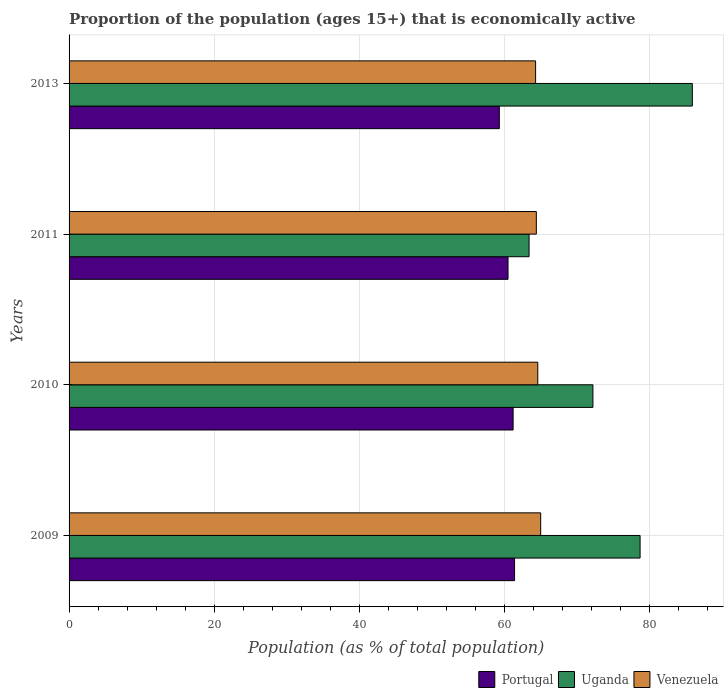How many groups of bars are there?
Provide a succinct answer. 4. Are the number of bars per tick equal to the number of legend labels?
Offer a very short reply. Yes. Are the number of bars on each tick of the Y-axis equal?
Provide a succinct answer. Yes. How many bars are there on the 3rd tick from the top?
Keep it short and to the point. 3. What is the proportion of the population that is economically active in Venezuela in 2010?
Offer a very short reply. 64.6. Across all years, what is the maximum proportion of the population that is economically active in Venezuela?
Keep it short and to the point. 65. Across all years, what is the minimum proportion of the population that is economically active in Venezuela?
Give a very brief answer. 64.3. In which year was the proportion of the population that is economically active in Venezuela minimum?
Give a very brief answer. 2013. What is the total proportion of the population that is economically active in Venezuela in the graph?
Provide a succinct answer. 258.3. What is the difference between the proportion of the population that is economically active in Venezuela in 2009 and that in 2010?
Keep it short and to the point. 0.4. What is the difference between the proportion of the population that is economically active in Portugal in 2009 and the proportion of the population that is economically active in Venezuela in 2011?
Provide a short and direct response. -3. What is the average proportion of the population that is economically active in Uganda per year?
Your answer should be very brief. 75.05. In the year 2011, what is the difference between the proportion of the population that is economically active in Venezuela and proportion of the population that is economically active in Portugal?
Keep it short and to the point. 3.9. In how many years, is the proportion of the population that is economically active in Venezuela greater than 20 %?
Your answer should be very brief. 4. What is the ratio of the proportion of the population that is economically active in Uganda in 2010 to that in 2011?
Offer a very short reply. 1.14. Is the proportion of the population that is economically active in Uganda in 2009 less than that in 2013?
Your answer should be very brief. Yes. What is the difference between the highest and the second highest proportion of the population that is economically active in Venezuela?
Your response must be concise. 0.4. What is the difference between the highest and the lowest proportion of the population that is economically active in Uganda?
Make the answer very short. 22.5. What does the 2nd bar from the top in 2010 represents?
Make the answer very short. Uganda. What does the 2nd bar from the bottom in 2009 represents?
Give a very brief answer. Uganda. Is it the case that in every year, the sum of the proportion of the population that is economically active in Venezuela and proportion of the population that is economically active in Uganda is greater than the proportion of the population that is economically active in Portugal?
Provide a short and direct response. Yes. Does the graph contain any zero values?
Offer a very short reply. No. How are the legend labels stacked?
Ensure brevity in your answer.  Horizontal. What is the title of the graph?
Provide a short and direct response. Proportion of the population (ages 15+) that is economically active. What is the label or title of the X-axis?
Provide a succinct answer. Population (as % of total population). What is the Population (as % of total population) of Portugal in 2009?
Keep it short and to the point. 61.4. What is the Population (as % of total population) of Uganda in 2009?
Your answer should be very brief. 78.7. What is the Population (as % of total population) in Venezuela in 2009?
Offer a terse response. 65. What is the Population (as % of total population) of Portugal in 2010?
Provide a short and direct response. 61.2. What is the Population (as % of total population) of Uganda in 2010?
Your response must be concise. 72.2. What is the Population (as % of total population) of Venezuela in 2010?
Your answer should be compact. 64.6. What is the Population (as % of total population) of Portugal in 2011?
Provide a succinct answer. 60.5. What is the Population (as % of total population) of Uganda in 2011?
Provide a succinct answer. 63.4. What is the Population (as % of total population) of Venezuela in 2011?
Provide a short and direct response. 64.4. What is the Population (as % of total population) in Portugal in 2013?
Provide a short and direct response. 59.3. What is the Population (as % of total population) in Uganda in 2013?
Offer a very short reply. 85.9. What is the Population (as % of total population) of Venezuela in 2013?
Make the answer very short. 64.3. Across all years, what is the maximum Population (as % of total population) in Portugal?
Offer a very short reply. 61.4. Across all years, what is the maximum Population (as % of total population) in Uganda?
Your answer should be very brief. 85.9. Across all years, what is the maximum Population (as % of total population) in Venezuela?
Your answer should be very brief. 65. Across all years, what is the minimum Population (as % of total population) of Portugal?
Offer a terse response. 59.3. Across all years, what is the minimum Population (as % of total population) of Uganda?
Provide a short and direct response. 63.4. Across all years, what is the minimum Population (as % of total population) of Venezuela?
Make the answer very short. 64.3. What is the total Population (as % of total population) in Portugal in the graph?
Keep it short and to the point. 242.4. What is the total Population (as % of total population) of Uganda in the graph?
Keep it short and to the point. 300.2. What is the total Population (as % of total population) in Venezuela in the graph?
Ensure brevity in your answer.  258.3. What is the difference between the Population (as % of total population) of Portugal in 2009 and that in 2010?
Your answer should be compact. 0.2. What is the difference between the Population (as % of total population) of Uganda in 2009 and that in 2010?
Provide a short and direct response. 6.5. What is the difference between the Population (as % of total population) of Uganda in 2009 and that in 2011?
Ensure brevity in your answer.  15.3. What is the difference between the Population (as % of total population) of Portugal in 2009 and that in 2013?
Ensure brevity in your answer.  2.1. What is the difference between the Population (as % of total population) in Uganda in 2009 and that in 2013?
Ensure brevity in your answer.  -7.2. What is the difference between the Population (as % of total population) of Venezuela in 2009 and that in 2013?
Provide a short and direct response. 0.7. What is the difference between the Population (as % of total population) in Uganda in 2010 and that in 2011?
Keep it short and to the point. 8.8. What is the difference between the Population (as % of total population) of Uganda in 2010 and that in 2013?
Offer a very short reply. -13.7. What is the difference between the Population (as % of total population) in Venezuela in 2010 and that in 2013?
Offer a very short reply. 0.3. What is the difference between the Population (as % of total population) in Portugal in 2011 and that in 2013?
Provide a short and direct response. 1.2. What is the difference between the Population (as % of total population) in Uganda in 2011 and that in 2013?
Offer a terse response. -22.5. What is the difference between the Population (as % of total population) in Venezuela in 2011 and that in 2013?
Ensure brevity in your answer.  0.1. What is the difference between the Population (as % of total population) of Portugal in 2009 and the Population (as % of total population) of Uganda in 2010?
Make the answer very short. -10.8. What is the difference between the Population (as % of total population) of Uganda in 2009 and the Population (as % of total population) of Venezuela in 2010?
Provide a short and direct response. 14.1. What is the difference between the Population (as % of total population) in Portugal in 2009 and the Population (as % of total population) in Venezuela in 2011?
Provide a succinct answer. -3. What is the difference between the Population (as % of total population) of Uganda in 2009 and the Population (as % of total population) of Venezuela in 2011?
Provide a short and direct response. 14.3. What is the difference between the Population (as % of total population) in Portugal in 2009 and the Population (as % of total population) in Uganda in 2013?
Your response must be concise. -24.5. What is the difference between the Population (as % of total population) in Portugal in 2010 and the Population (as % of total population) in Uganda in 2013?
Make the answer very short. -24.7. What is the difference between the Population (as % of total population) of Portugal in 2010 and the Population (as % of total population) of Venezuela in 2013?
Keep it short and to the point. -3.1. What is the difference between the Population (as % of total population) of Uganda in 2010 and the Population (as % of total population) of Venezuela in 2013?
Your answer should be compact. 7.9. What is the difference between the Population (as % of total population) of Portugal in 2011 and the Population (as % of total population) of Uganda in 2013?
Give a very brief answer. -25.4. What is the difference between the Population (as % of total population) in Uganda in 2011 and the Population (as % of total population) in Venezuela in 2013?
Give a very brief answer. -0.9. What is the average Population (as % of total population) in Portugal per year?
Ensure brevity in your answer.  60.6. What is the average Population (as % of total population) of Uganda per year?
Keep it short and to the point. 75.05. What is the average Population (as % of total population) in Venezuela per year?
Offer a very short reply. 64.58. In the year 2009, what is the difference between the Population (as % of total population) in Portugal and Population (as % of total population) in Uganda?
Your answer should be compact. -17.3. In the year 2009, what is the difference between the Population (as % of total population) in Uganda and Population (as % of total population) in Venezuela?
Offer a terse response. 13.7. In the year 2011, what is the difference between the Population (as % of total population) in Uganda and Population (as % of total population) in Venezuela?
Your answer should be compact. -1. In the year 2013, what is the difference between the Population (as % of total population) in Portugal and Population (as % of total population) in Uganda?
Ensure brevity in your answer.  -26.6. In the year 2013, what is the difference between the Population (as % of total population) of Uganda and Population (as % of total population) of Venezuela?
Offer a terse response. 21.6. What is the ratio of the Population (as % of total population) of Portugal in 2009 to that in 2010?
Make the answer very short. 1. What is the ratio of the Population (as % of total population) of Uganda in 2009 to that in 2010?
Make the answer very short. 1.09. What is the ratio of the Population (as % of total population) of Portugal in 2009 to that in 2011?
Ensure brevity in your answer.  1.01. What is the ratio of the Population (as % of total population) in Uganda in 2009 to that in 2011?
Provide a succinct answer. 1.24. What is the ratio of the Population (as % of total population) of Venezuela in 2009 to that in 2011?
Offer a terse response. 1.01. What is the ratio of the Population (as % of total population) in Portugal in 2009 to that in 2013?
Make the answer very short. 1.04. What is the ratio of the Population (as % of total population) in Uganda in 2009 to that in 2013?
Offer a terse response. 0.92. What is the ratio of the Population (as % of total population) of Venezuela in 2009 to that in 2013?
Provide a short and direct response. 1.01. What is the ratio of the Population (as % of total population) in Portugal in 2010 to that in 2011?
Provide a succinct answer. 1.01. What is the ratio of the Population (as % of total population) of Uganda in 2010 to that in 2011?
Your answer should be compact. 1.14. What is the ratio of the Population (as % of total population) of Venezuela in 2010 to that in 2011?
Ensure brevity in your answer.  1. What is the ratio of the Population (as % of total population) in Portugal in 2010 to that in 2013?
Provide a succinct answer. 1.03. What is the ratio of the Population (as % of total population) of Uganda in 2010 to that in 2013?
Ensure brevity in your answer.  0.84. What is the ratio of the Population (as % of total population) in Venezuela in 2010 to that in 2013?
Your response must be concise. 1. What is the ratio of the Population (as % of total population) in Portugal in 2011 to that in 2013?
Provide a short and direct response. 1.02. What is the ratio of the Population (as % of total population) of Uganda in 2011 to that in 2013?
Offer a terse response. 0.74. What is the difference between the highest and the second highest Population (as % of total population) in Portugal?
Ensure brevity in your answer.  0.2. What is the difference between the highest and the second highest Population (as % of total population) in Uganda?
Your answer should be compact. 7.2. What is the difference between the highest and the lowest Population (as % of total population) in Portugal?
Make the answer very short. 2.1. 